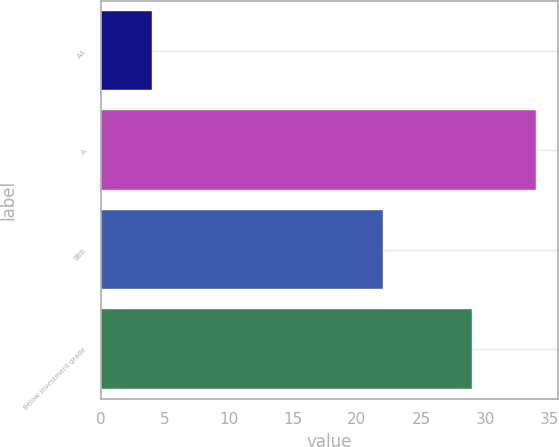<chart> <loc_0><loc_0><loc_500><loc_500><bar_chart><fcel>AA<fcel>A<fcel>BBB<fcel>Below investment grade<nl><fcel>4<fcel>34<fcel>22<fcel>29<nl></chart> 